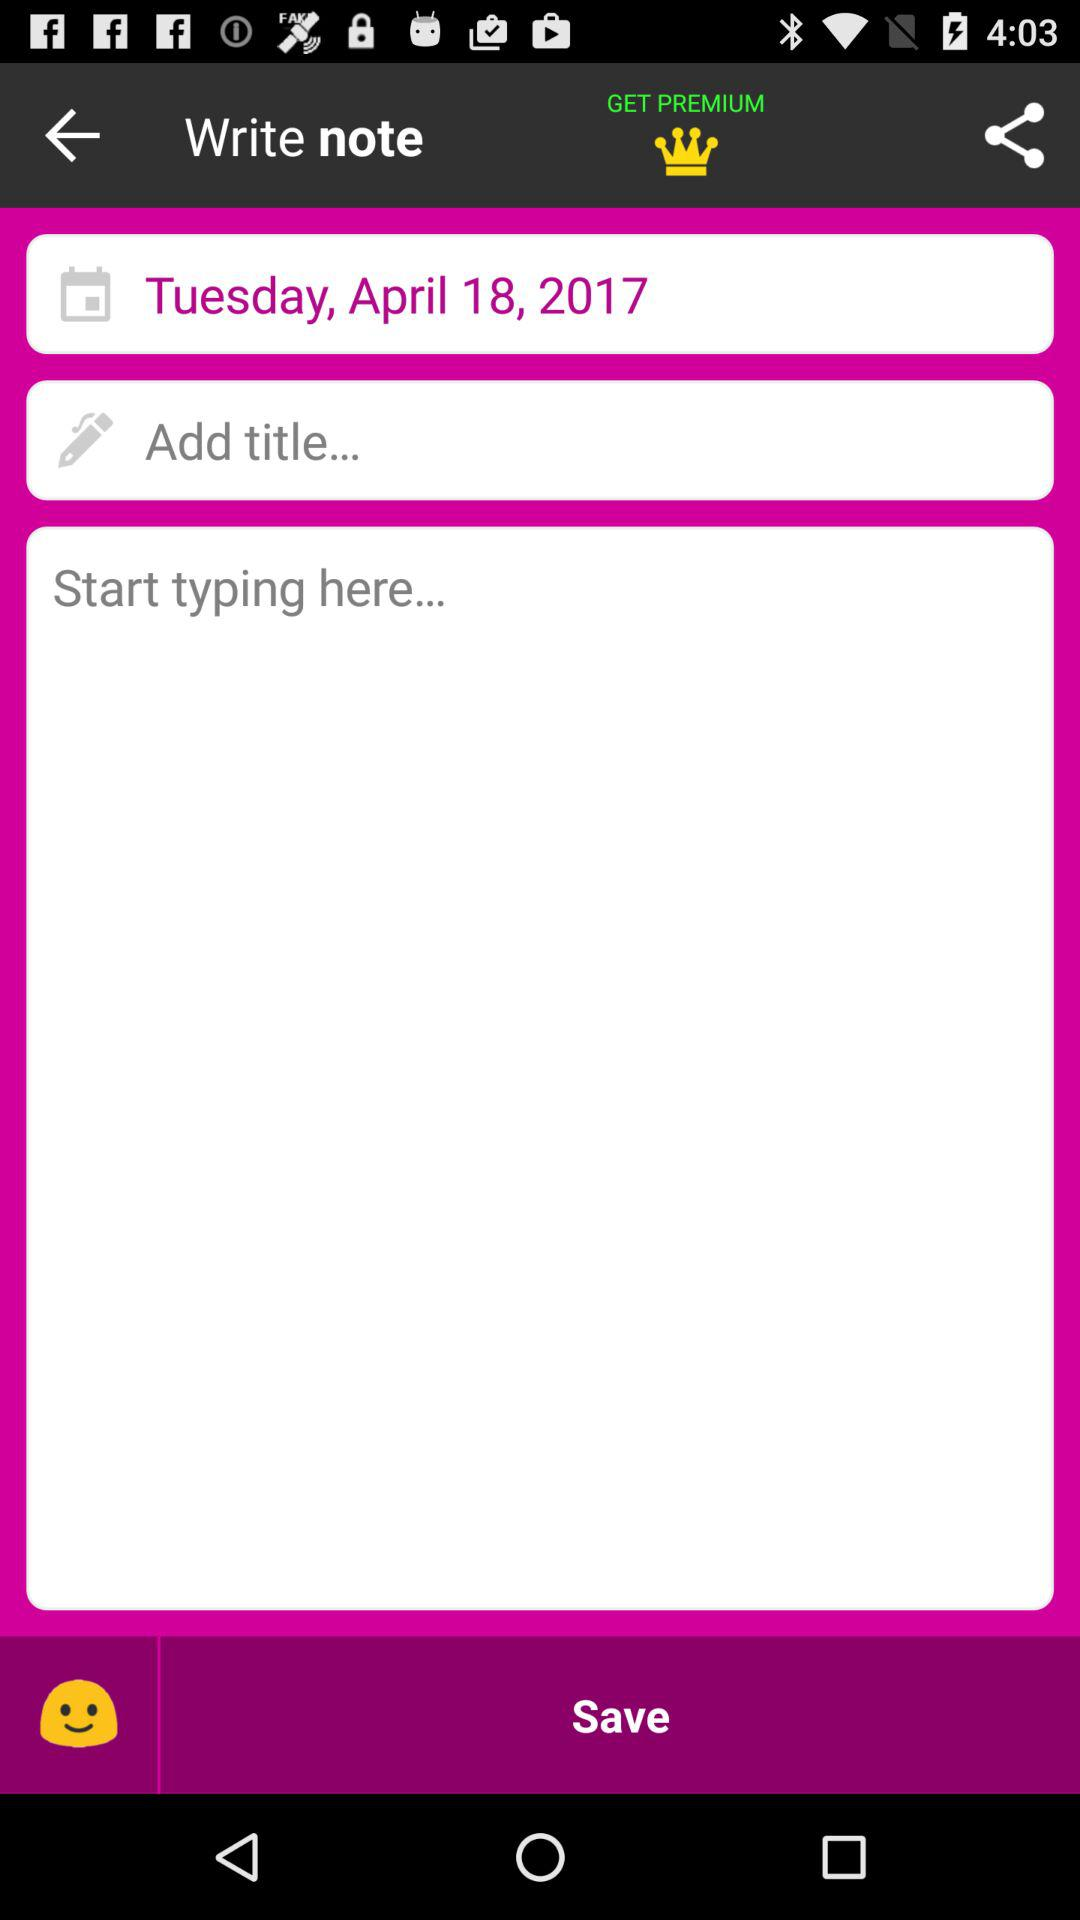What is the day and date mentioned? The day and date mentioned is Tuesday, April 18, 2017. 